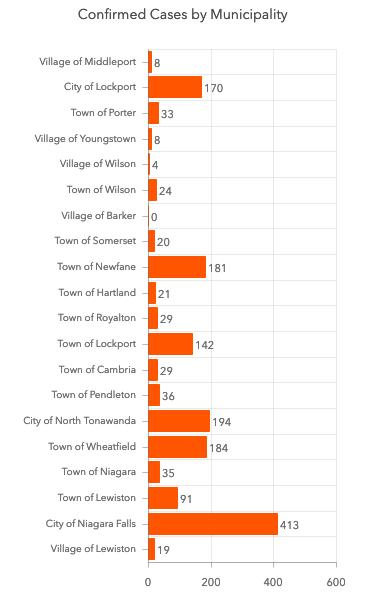Indicate a few pertinent items in this graphic. The city of Niagara Falls has reported the highest number of confirmed COVID-19 cases, making it the city with the highest number of cases. There are currently 170 confirmed cases of COVID-19 reported in the City of Lockport. The Village of Wilson has reported a total of 4 confirmed COVID-19 cases. 